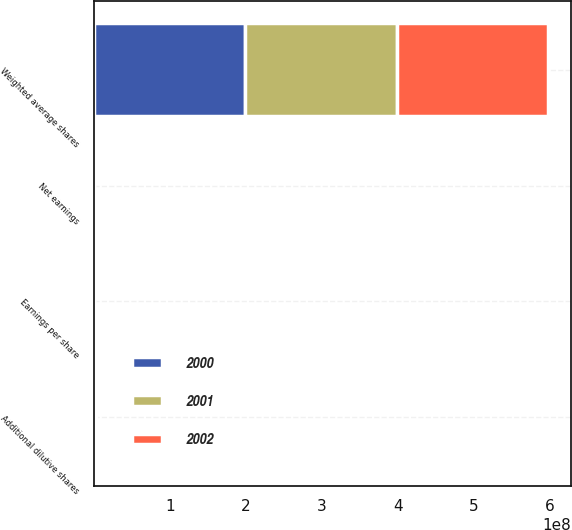Convert chart to OTSL. <chart><loc_0><loc_0><loc_500><loc_500><stacked_bar_chart><ecel><fcel>Weighted average shares<fcel>Net earnings<fcel>Earnings per share<fcel>Additional dilutive shares<nl><fcel>2001<fcel>1.98971e+08<fcel>233.1<fcel>1.17<fcel>823730<nl><fcel>2000<fcel>1.99457e+08<fcel>187.6<fcel>0.94<fcel>977404<nl><fcel>2002<fcel>1.98987e+08<fcel>264.1<fcel>1.33<fcel>1.40152e+06<nl></chart> 